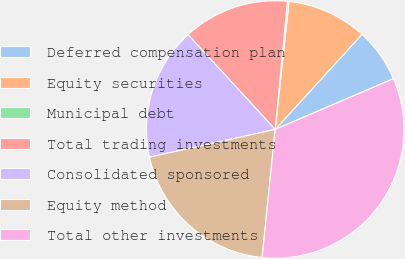Convert chart to OTSL. <chart><loc_0><loc_0><loc_500><loc_500><pie_chart><fcel>Deferred compensation plan<fcel>Equity securities<fcel>Municipal debt<fcel>Total trading investments<fcel>Consolidated sponsored<fcel>Equity method<fcel>Total other investments<nl><fcel>6.77%<fcel>10.06%<fcel>0.2%<fcel>13.35%<fcel>16.63%<fcel>19.92%<fcel>33.07%<nl></chart> 